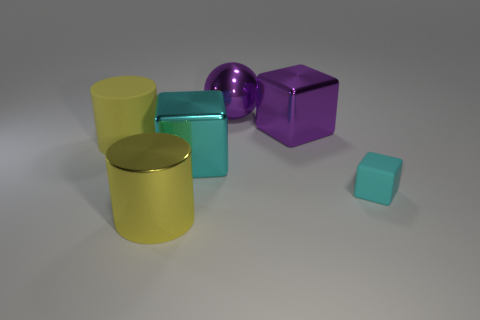Are there any other things that are the same size as the cyan matte object?
Give a very brief answer. No. Is there a big cube that has the same color as the tiny rubber thing?
Offer a very short reply. Yes. What is the material of the thing that is the same color as the tiny rubber cube?
Keep it short and to the point. Metal. What number of other metallic cylinders are the same color as the big shiny cylinder?
Ensure brevity in your answer.  0. How many objects are either big yellow objects that are on the right side of the yellow matte cylinder or cyan rubber blocks?
Offer a terse response. 2. What color is the cylinder that is the same material as the sphere?
Ensure brevity in your answer.  Yellow. Is there a blue matte sphere that has the same size as the purple metallic ball?
Give a very brief answer. No. How many objects are either big shiny things that are in front of the purple metallic block or big yellow cylinders behind the tiny matte cube?
Provide a succinct answer. 3. There is a matte thing that is the same size as the ball; what shape is it?
Your response must be concise. Cylinder. Are there any shiny things that have the same shape as the cyan matte object?
Your response must be concise. Yes. 